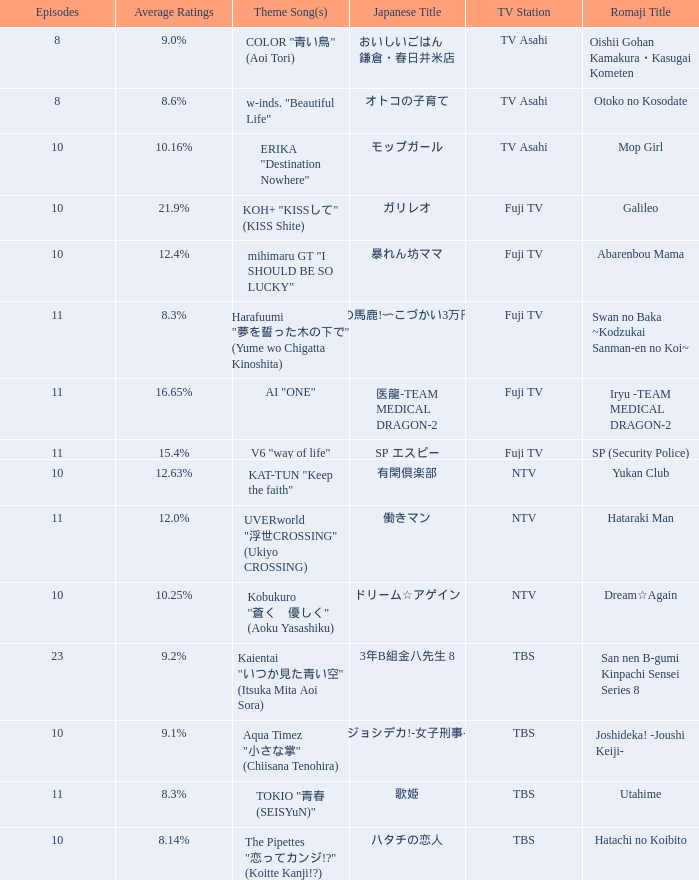What song serves as the theme for iryu -team medical dragon- 2? AI "ONE". 